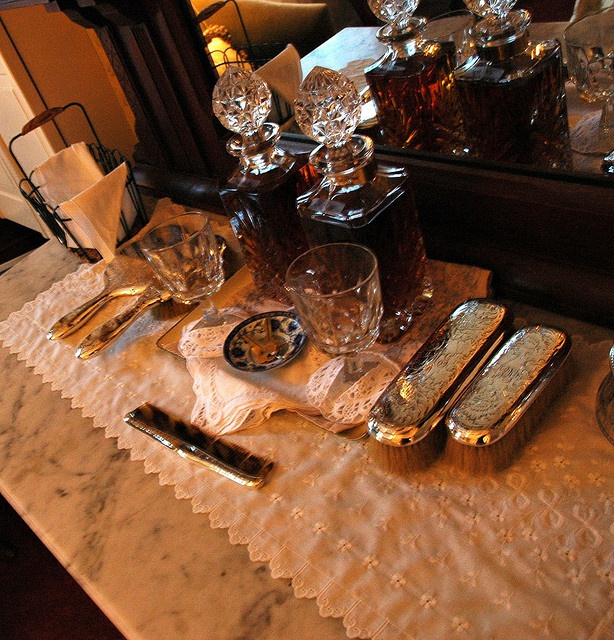Describe the objects in this image and their specific colors. I can see dining table in maroon, brown, salmon, and tan tones, bottle in maroon, black, and gray tones, bottle in maroon, black, and gray tones, wine glass in maroon, black, and brown tones, and bottle in maroon, black, gray, and white tones in this image. 